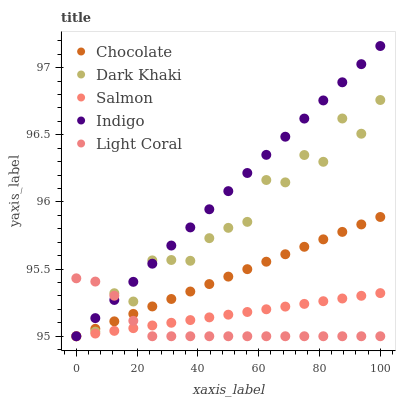Does Light Coral have the minimum area under the curve?
Answer yes or no. Yes. Does Indigo have the maximum area under the curve?
Answer yes or no. Yes. Does Salmon have the minimum area under the curve?
Answer yes or no. No. Does Salmon have the maximum area under the curve?
Answer yes or no. No. Is Indigo the smoothest?
Answer yes or no. Yes. Is Dark Khaki the roughest?
Answer yes or no. Yes. Is Salmon the smoothest?
Answer yes or no. No. Is Salmon the roughest?
Answer yes or no. No. Does Dark Khaki have the lowest value?
Answer yes or no. Yes. Does Indigo have the highest value?
Answer yes or no. Yes. Does Salmon have the highest value?
Answer yes or no. No. Does Chocolate intersect Indigo?
Answer yes or no. Yes. Is Chocolate less than Indigo?
Answer yes or no. No. Is Chocolate greater than Indigo?
Answer yes or no. No. 